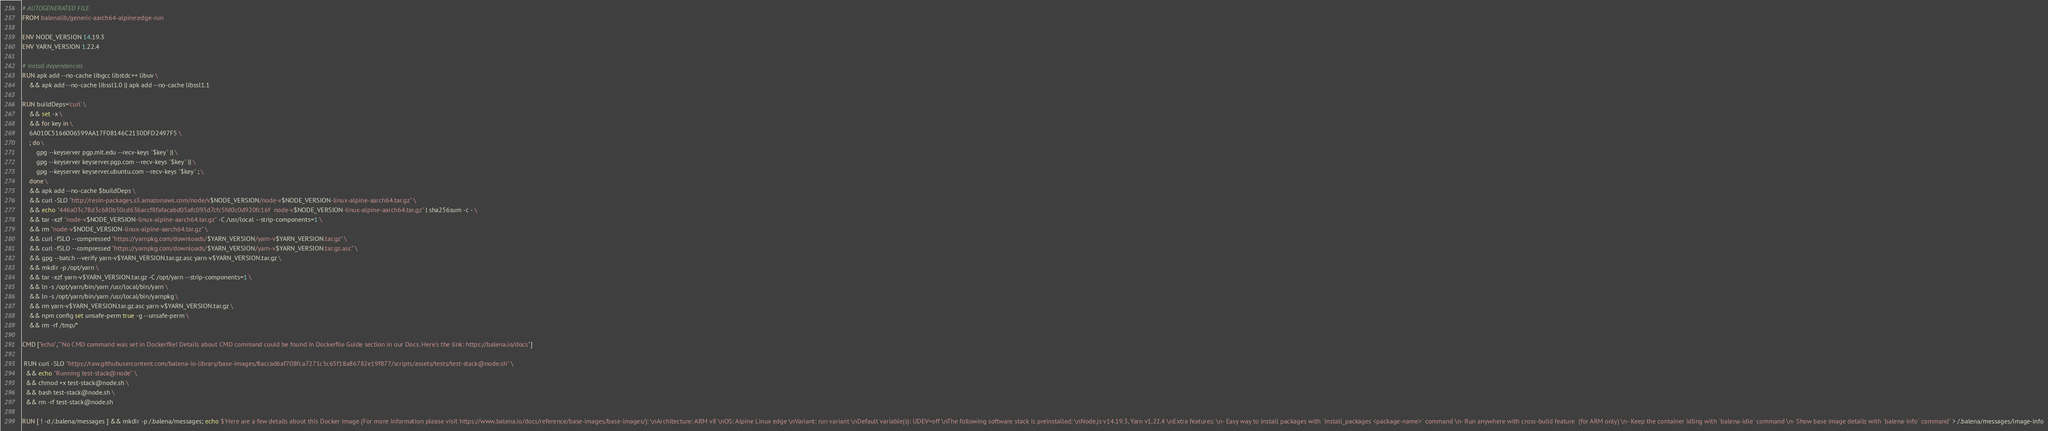<code> <loc_0><loc_0><loc_500><loc_500><_Dockerfile_># AUTOGENERATED FILE
FROM balenalib/generic-aarch64-alpine:edge-run

ENV NODE_VERSION 14.19.3
ENV YARN_VERSION 1.22.4

# Install dependencies
RUN apk add --no-cache libgcc libstdc++ libuv \
	&& apk add --no-cache libssl1.0 || apk add --no-cache libssl1.1

RUN buildDeps='curl' \
	&& set -x \
	&& for key in \
	6A010C5166006599AA17F08146C2130DFD2497F5 \
	; do \
		gpg --keyserver pgp.mit.edu --recv-keys "$key" || \
		gpg --keyserver keyserver.pgp.com --recv-keys "$key" || \
		gpg --keyserver keyserver.ubuntu.com --recv-keys "$key" ; \
	done \
	&& apk add --no-cache $buildDeps \
	&& curl -SLO "http://resin-packages.s3.amazonaws.com/node/v$NODE_VERSION/node-v$NODE_VERSION-linux-alpine-aarch64.tar.gz" \
	&& echo "446a03c78d3c680b50cd636accf8fafacabd05afc093d7cfc5fd0c0d920fc16f  node-v$NODE_VERSION-linux-alpine-aarch64.tar.gz" | sha256sum -c - \
	&& tar -xzf "node-v$NODE_VERSION-linux-alpine-aarch64.tar.gz" -C /usr/local --strip-components=1 \
	&& rm "node-v$NODE_VERSION-linux-alpine-aarch64.tar.gz" \
	&& curl -fSLO --compressed "https://yarnpkg.com/downloads/$YARN_VERSION/yarn-v$YARN_VERSION.tar.gz" \
	&& curl -fSLO --compressed "https://yarnpkg.com/downloads/$YARN_VERSION/yarn-v$YARN_VERSION.tar.gz.asc" \
	&& gpg --batch --verify yarn-v$YARN_VERSION.tar.gz.asc yarn-v$YARN_VERSION.tar.gz \
	&& mkdir -p /opt/yarn \
	&& tar -xzf yarn-v$YARN_VERSION.tar.gz -C /opt/yarn --strip-components=1 \
	&& ln -s /opt/yarn/bin/yarn /usr/local/bin/yarn \
	&& ln -s /opt/yarn/bin/yarn /usr/local/bin/yarnpkg \
	&& rm yarn-v$YARN_VERSION.tar.gz.asc yarn-v$YARN_VERSION.tar.gz \
	&& npm config set unsafe-perm true -g --unsafe-perm \
	&& rm -rf /tmp/*

CMD ["echo","'No CMD command was set in Dockerfile! Details about CMD command could be found in Dockerfile Guide section in our Docs. Here's the link: https://balena.io/docs"]

 RUN curl -SLO "https://raw.githubusercontent.com/balena-io-library/base-images/8accad6af708fca7271c5c65f18a86782e19f877/scripts/assets/tests/test-stack@node.sh" \
  && echo "Running test-stack@node" \
  && chmod +x test-stack@node.sh \
  && bash test-stack@node.sh \
  && rm -rf test-stack@node.sh 

RUN [ ! -d /.balena/messages ] && mkdir -p /.balena/messages; echo $'Here are a few details about this Docker image (For more information please visit https://www.balena.io/docs/reference/base-images/base-images/): \nArchitecture: ARM v8 \nOS: Alpine Linux edge \nVariant: run variant \nDefault variable(s): UDEV=off \nThe following software stack is preinstalled: \nNode.js v14.19.3, Yarn v1.22.4 \nExtra features: \n- Easy way to install packages with `install_packages <package-name>` command \n- Run anywhere with cross-build feature  (for ARM only) \n- Keep the container idling with `balena-idle` command \n- Show base image details with `balena-info` command' > /.balena/messages/image-info</code> 